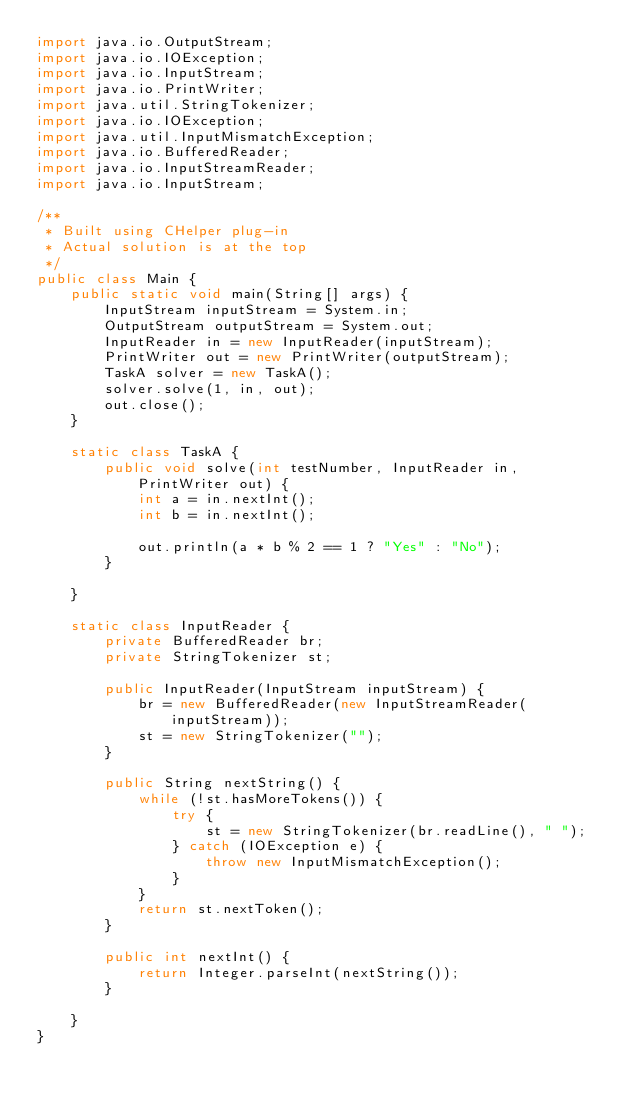<code> <loc_0><loc_0><loc_500><loc_500><_Java_>import java.io.OutputStream;
import java.io.IOException;
import java.io.InputStream;
import java.io.PrintWriter;
import java.util.StringTokenizer;
import java.io.IOException;
import java.util.InputMismatchException;
import java.io.BufferedReader;
import java.io.InputStreamReader;
import java.io.InputStream;

/**
 * Built using CHelper plug-in
 * Actual solution is at the top
 */
public class Main {
    public static void main(String[] args) {
        InputStream inputStream = System.in;
        OutputStream outputStream = System.out;
        InputReader in = new InputReader(inputStream);
        PrintWriter out = new PrintWriter(outputStream);
        TaskA solver = new TaskA();
        solver.solve(1, in, out);
        out.close();
    }

    static class TaskA {
        public void solve(int testNumber, InputReader in, PrintWriter out) {
            int a = in.nextInt();
            int b = in.nextInt();

            out.println(a * b % 2 == 1 ? "Yes" : "No");
        }

    }

    static class InputReader {
        private BufferedReader br;
        private StringTokenizer st;

        public InputReader(InputStream inputStream) {
            br = new BufferedReader(new InputStreamReader(inputStream));
            st = new StringTokenizer("");
        }

        public String nextString() {
            while (!st.hasMoreTokens()) {
                try {
                    st = new StringTokenizer(br.readLine(), " ");
                } catch (IOException e) {
                    throw new InputMismatchException();
                }
            }
            return st.nextToken();
        }

        public int nextInt() {
            return Integer.parseInt(nextString());
        }

    }
}

</code> 